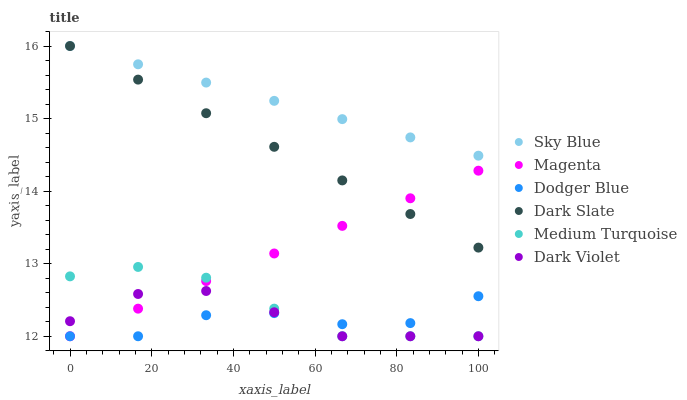Does Dodger Blue have the minimum area under the curve?
Answer yes or no. Yes. Does Sky Blue have the maximum area under the curve?
Answer yes or no. Yes. Does Dark Slate have the minimum area under the curve?
Answer yes or no. No. Does Dark Slate have the maximum area under the curve?
Answer yes or no. No. Is Dark Slate the smoothest?
Answer yes or no. Yes. Is Dodger Blue the roughest?
Answer yes or no. Yes. Is Dodger Blue the smoothest?
Answer yes or no. No. Is Dark Slate the roughest?
Answer yes or no. No. Does Dark Violet have the lowest value?
Answer yes or no. Yes. Does Dark Slate have the lowest value?
Answer yes or no. No. Does Sky Blue have the highest value?
Answer yes or no. Yes. Does Dodger Blue have the highest value?
Answer yes or no. No. Is Dodger Blue less than Dark Slate?
Answer yes or no. Yes. Is Dark Slate greater than Medium Turquoise?
Answer yes or no. Yes. Does Medium Turquoise intersect Dodger Blue?
Answer yes or no. Yes. Is Medium Turquoise less than Dodger Blue?
Answer yes or no. No. Is Medium Turquoise greater than Dodger Blue?
Answer yes or no. No. Does Dodger Blue intersect Dark Slate?
Answer yes or no. No. 